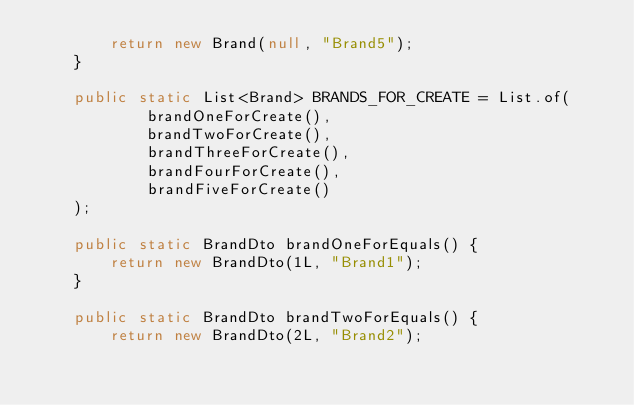Convert code to text. <code><loc_0><loc_0><loc_500><loc_500><_Java_>        return new Brand(null, "Brand5");
    }

    public static List<Brand> BRANDS_FOR_CREATE = List.of(
            brandOneForCreate(),
            brandTwoForCreate(),
            brandThreeForCreate(),
            brandFourForCreate(),
            brandFiveForCreate()
    );

    public static BrandDto brandOneForEquals() {
        return new BrandDto(1L, "Brand1");
    }

    public static BrandDto brandTwoForEquals() {
        return new BrandDto(2L, "Brand2");</code> 